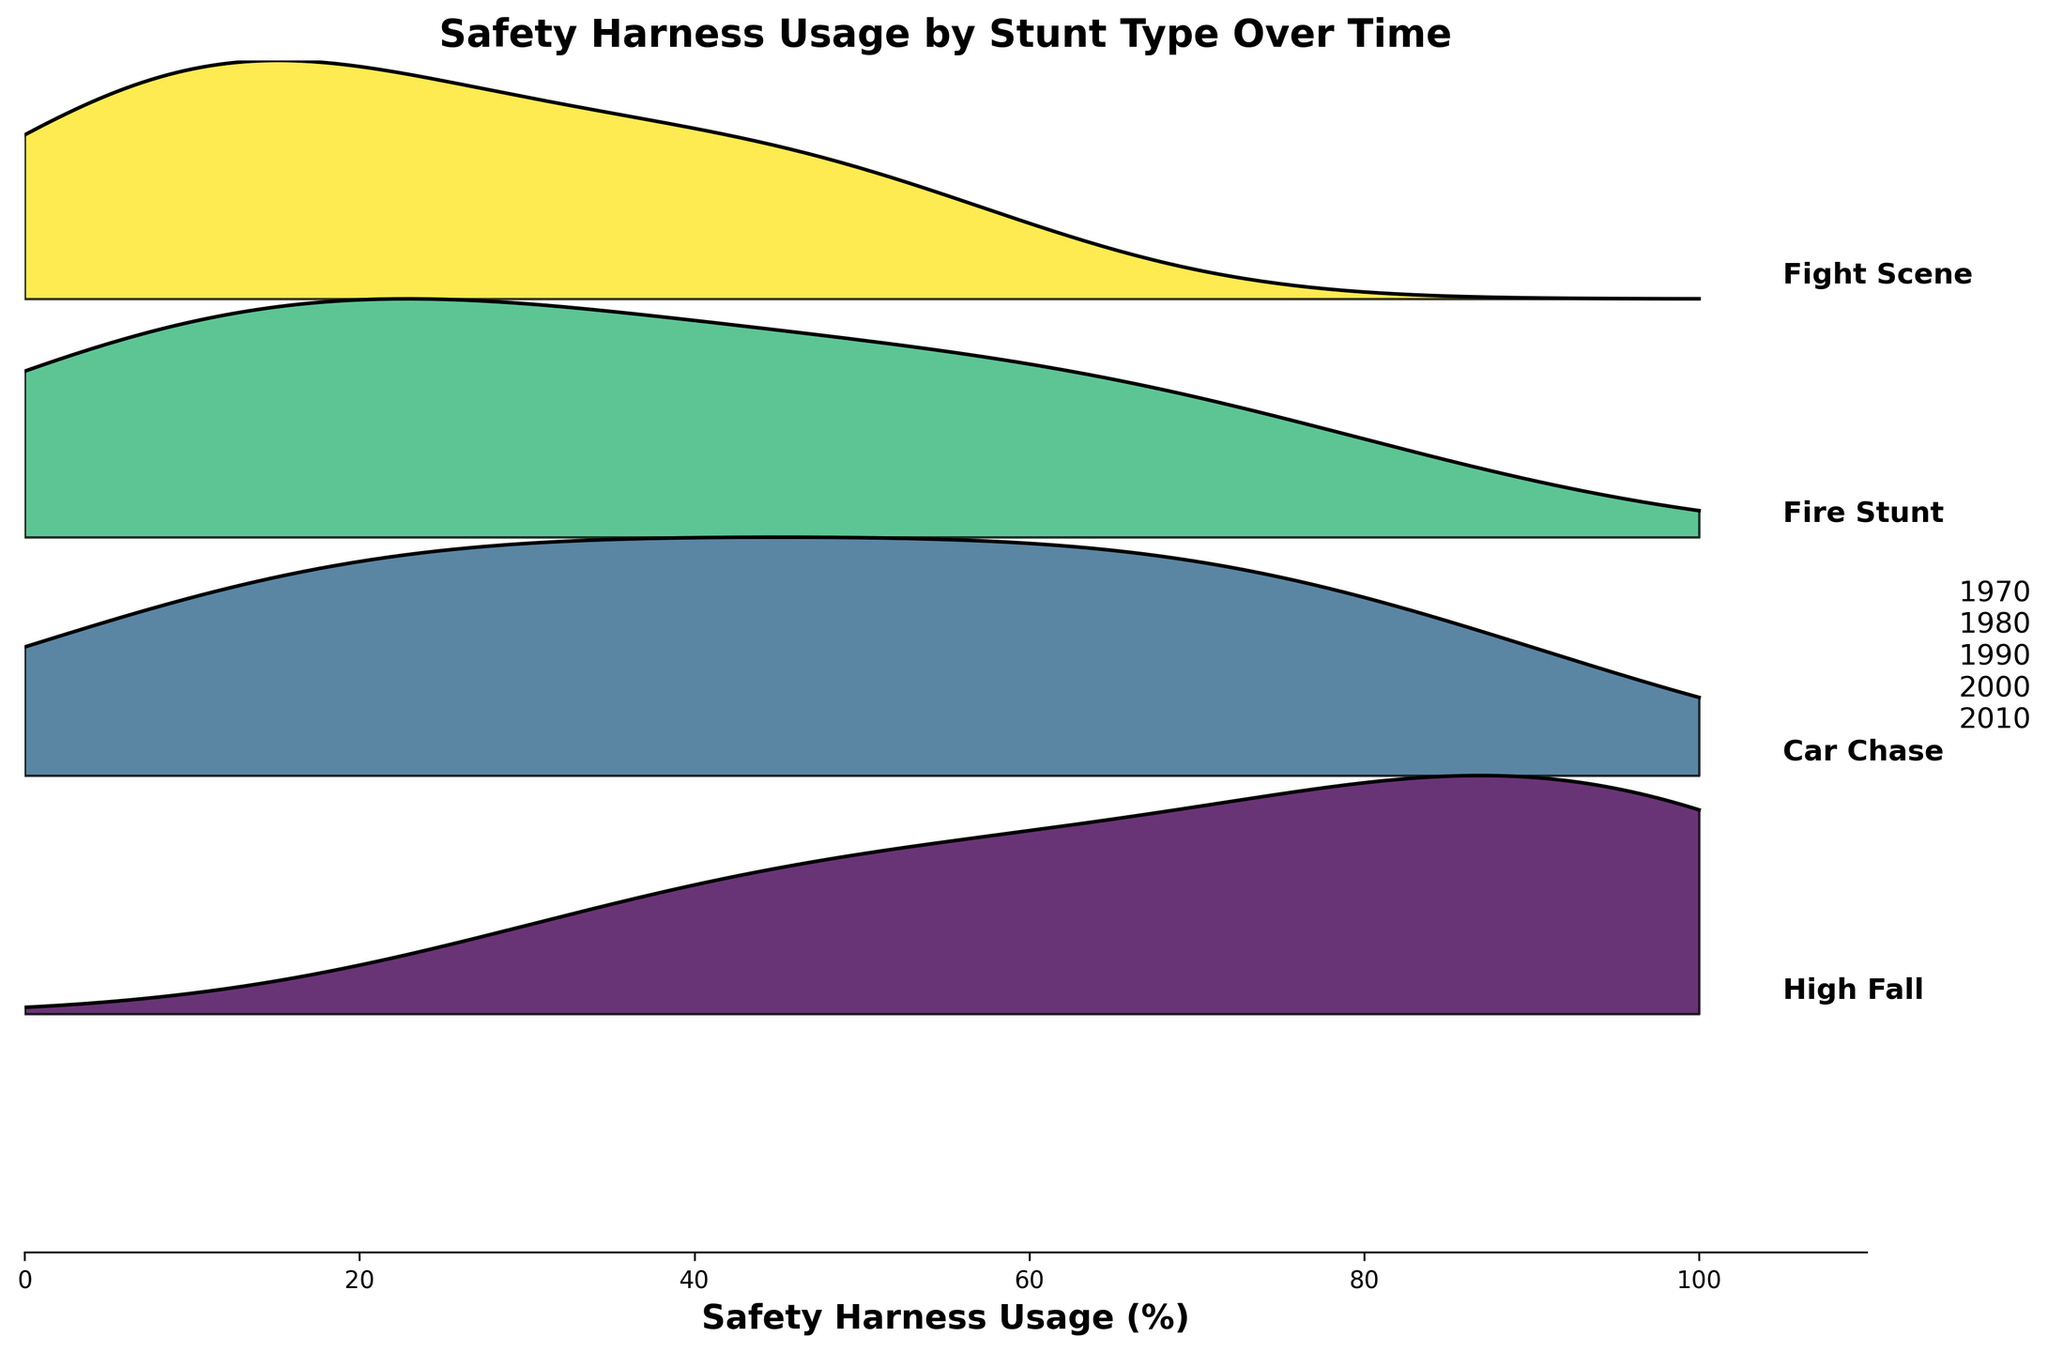What is the title of the figure? The title is prominently displayed at the top of the figure.
Answer: Safety Harness Usage by Stunt Type Over Time How many stunt types are shown in the figure? The figure labels each ridgeline plot with the name of the stunt type, and there are five lines labeled.
Answer: Five Which stunt type shows the highest usage of safety harness equipment by 2010? To determine this, observe the ridgeline plot for the highest values in 2010 and check the labels.
Answer: All stunt types are at 95% or higher by 2010 What is the trend in safety harness usage for the "High Fall" stunt type over the years? Look at the "High Fall" ridgeline plot and observe how the usage frequency increases with each subsequent year.
Answer: Increasing Compare the helmet usage in "Fight Scene" and "Fire Stunt" stunts over the years. Which one shows a sharper increase? To answer this, compare the slopes of the ridgeline plots for "Fight Scene" and "Fire Stunt" over the years. The steeper slope indicates a sharper increase.
Answer: Fight Scene Which stunt type had the lowest initial usage of safety harness in 1970? Check the ridgeline plot for each stunt type in 1970 and identify the lowest value.
Answer: Fire Stunt What does the x-axis represent in the figure? The x-axis label provides this information directly at the bottom of the figure.
Answer: Safety Harness Usage (%) Does the "Car Chase" stunt type ever exceed 80% usage of safety harness equipment? Examine the "Car Chase" ridgeline plot and check if the usage value ever crosses 80%.
Answer: Yes How does the 1990 safety harness usage in "Fire Stunt" compare to the 2000 usage in "Fight Scene"? Locate the 1990 value on the "Fire Stunt" plot and compare it with the 2000 value on the "Fight Scene" plot to see which one is higher.
Answer: Fire Stunt in 1990 is higher How are the years represented in the plot? The years are displayed on the y-axis as a vertical text.
Answer: As vertical text on the right side of the plot 